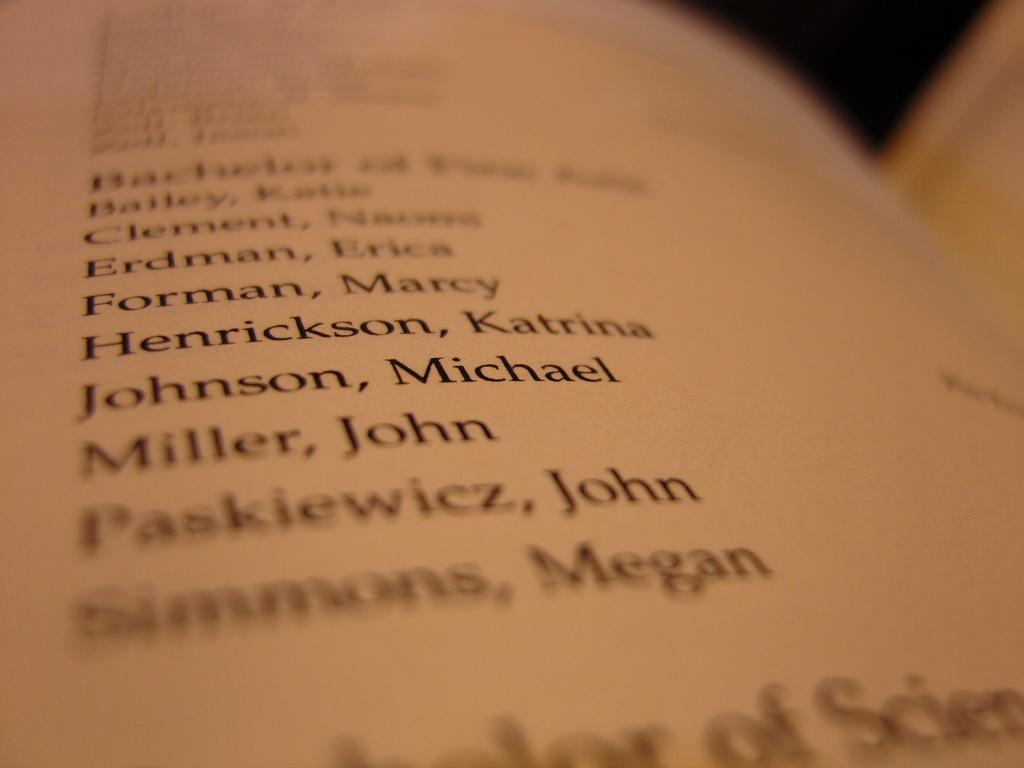<image>
Write a terse but informative summary of the picture. A book is open to a page with a list of names including Forman, Marcy. 